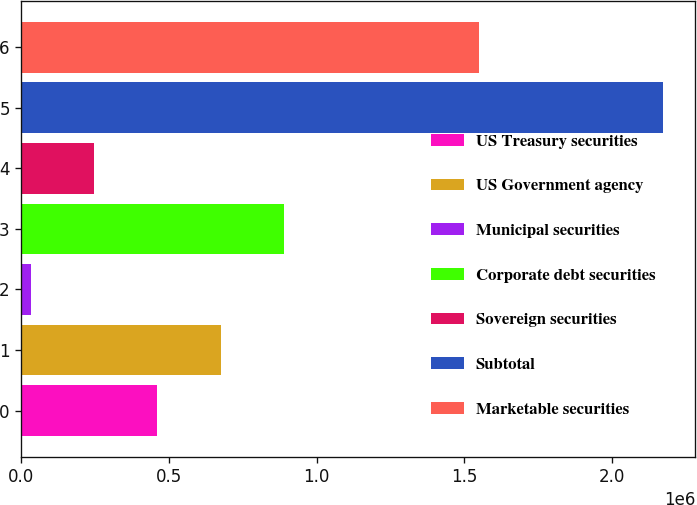Convert chart to OTSL. <chart><loc_0><loc_0><loc_500><loc_500><bar_chart><fcel>US Treasury securities<fcel>US Government agency<fcel>Municipal securities<fcel>Corporate debt securities<fcel>Sovereign securities<fcel>Subtotal<fcel>Marketable securities<nl><fcel>460268<fcel>674495<fcel>31816<fcel>888721<fcel>246042<fcel>2.17408e+06<fcel>1.54909e+06<nl></chart> 